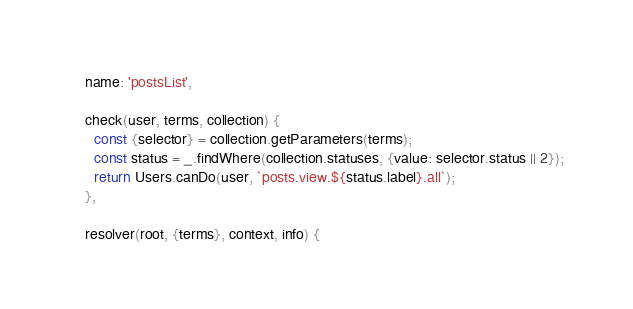Convert code to text. <code><loc_0><loc_0><loc_500><loc_500><_JavaScript_>
    name: 'postsList',

    check(user, terms, collection) {
      const {selector} = collection.getParameters(terms);
      const status = _.findWhere(collection.statuses, {value: selector.status || 2});
      return Users.canDo(user, `posts.view.${status.label}.all`);
    },

    resolver(root, {terms}, context, info) {</code> 